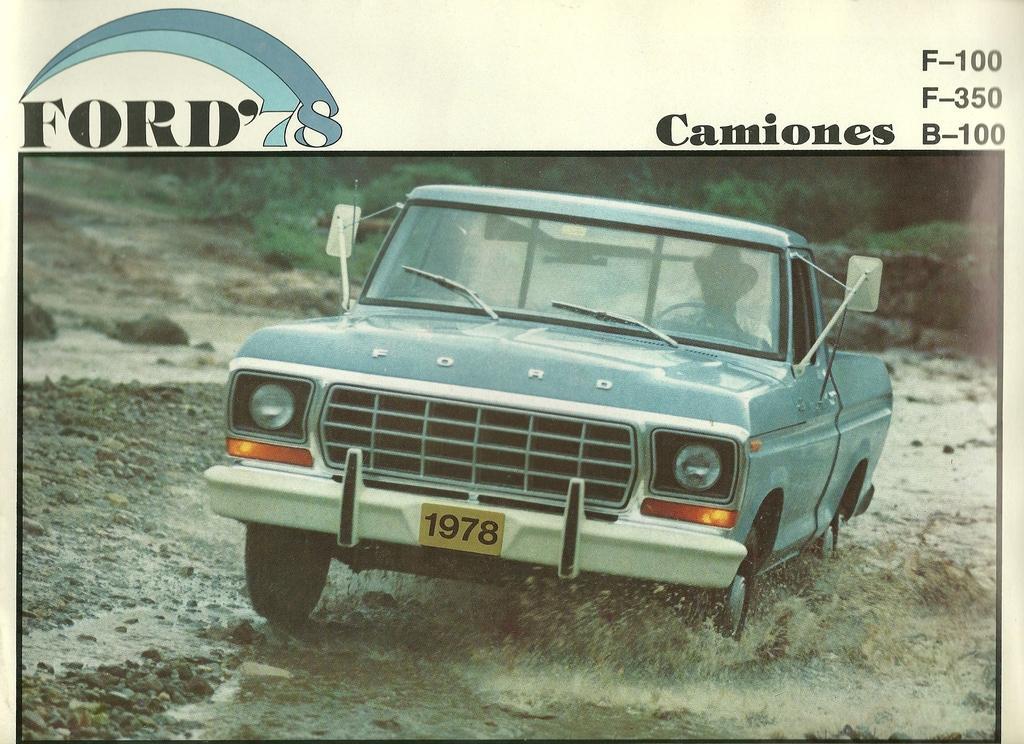How would you summarize this image in a sentence or two? This is a poster and in this poster we can see a car, mud, water, stones, plants and some text. 